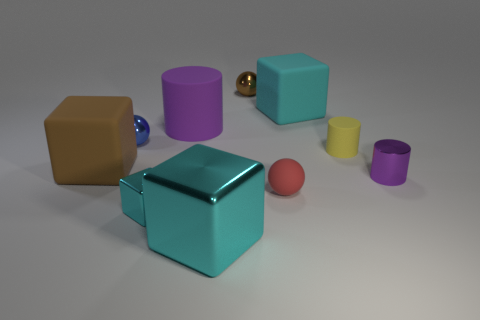Subtract all cyan blocks. How many were subtracted if there are2cyan blocks left? 1 Subtract all cylinders. How many objects are left? 7 Subtract 3 cubes. How many cubes are left? 1 Subtract all red cylinders. Subtract all blue spheres. How many cylinders are left? 3 Subtract all yellow cubes. How many purple cylinders are left? 2 Subtract all metal cylinders. Subtract all large matte cylinders. How many objects are left? 8 Add 7 red rubber objects. How many red rubber objects are left? 8 Add 1 small yellow matte things. How many small yellow matte things exist? 2 Subtract all blue balls. How many balls are left? 2 Subtract all blue shiny spheres. How many spheres are left? 2 